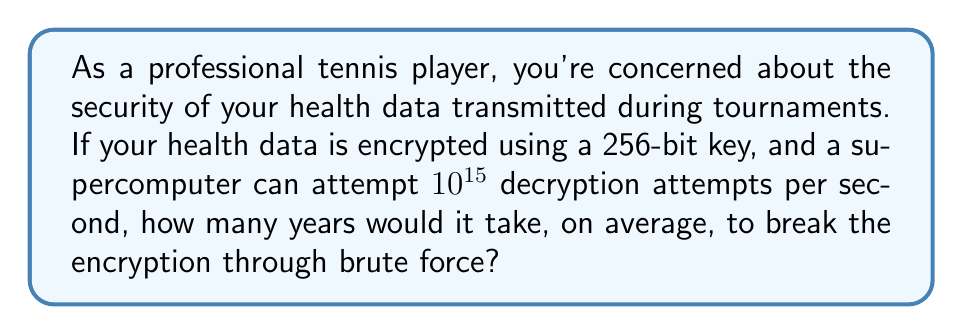Solve this math problem. Let's approach this step-by-step:

1) A 256-bit key has $2^{256}$ possible combinations.

2) On average, half of these combinations would need to be tried before finding the correct one. So, the expected number of attempts is:

   $$\frac{2^{256}}{2} = 2^{255}$$

3) The supercomputer can make $10^{15}$ attempts per second. Let's convert this to attempts per year:

   $$10^{15} \times 60 \times 60 \times 24 \times 365.25 = 3.1557 \times 10^{22}$$ attempts/year

4) Now, let's divide the number of required attempts by the attempts per year:

   $$\frac{2^{255}}{3.1557 \times 10^{22}}$$

5) To calculate this, let's convert $2^{255}$ to decimal:

   $2^{255} \approx 5.7896 \times 10^{76}$

6) Now we can perform the division:

   $$\frac{5.7896 \times 10^{76}}{3.1557 \times 10^{22}} \approx 1.8346 \times 10^{54}$$ years

This number is astronomically large, far exceeding the age of the universe (which is about $13.8 \times 10^9$ years).
Answer: $1.8346 \times 10^{54}$ years 